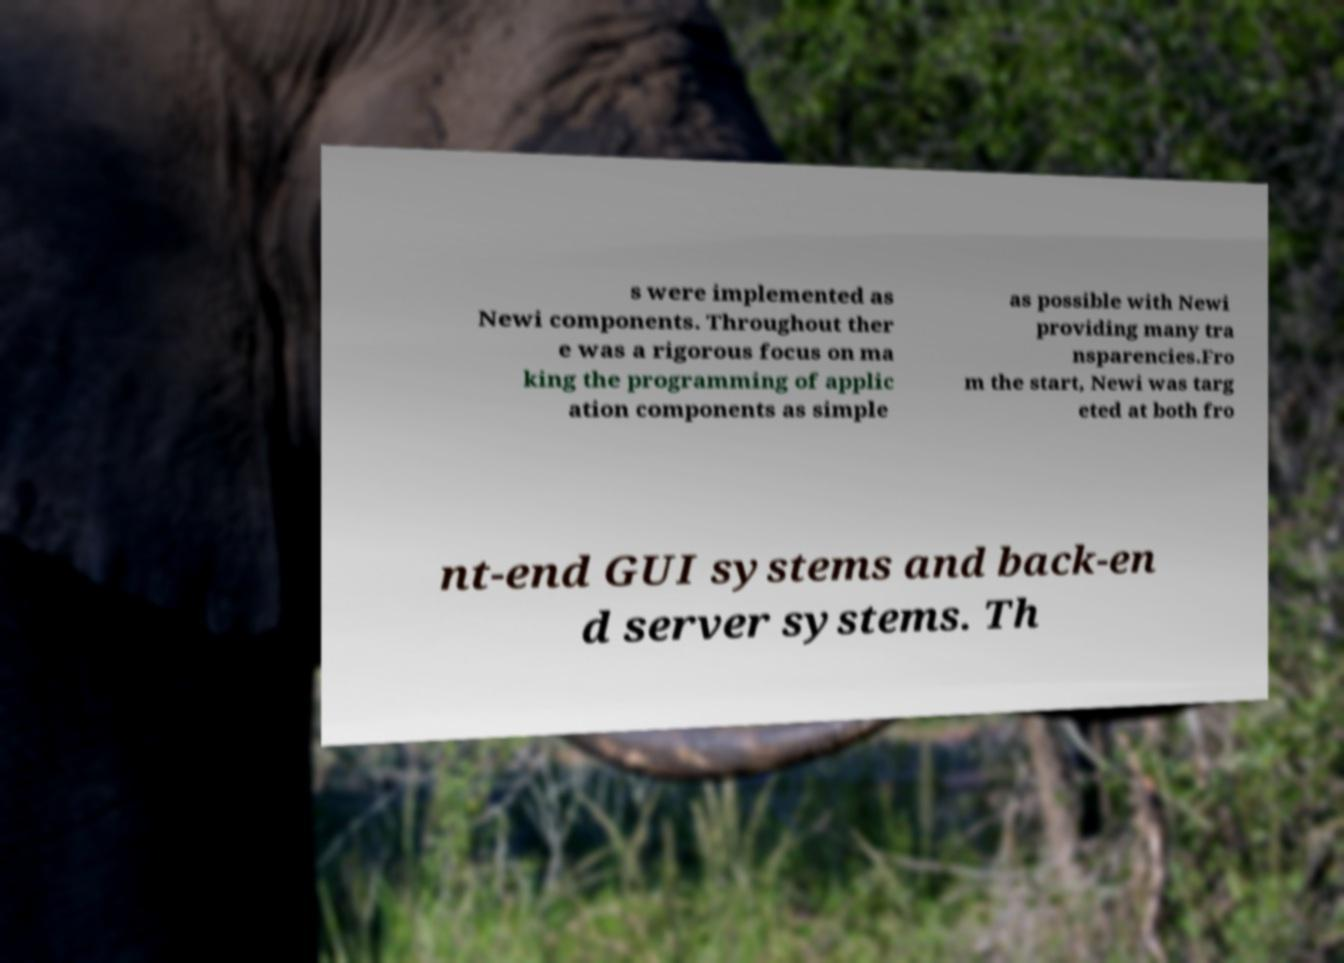Please identify and transcribe the text found in this image. s were implemented as Newi components. Throughout ther e was a rigorous focus on ma king the programming of applic ation components as simple as possible with Newi providing many tra nsparencies.Fro m the start, Newi was targ eted at both fro nt-end GUI systems and back-en d server systems. Th 